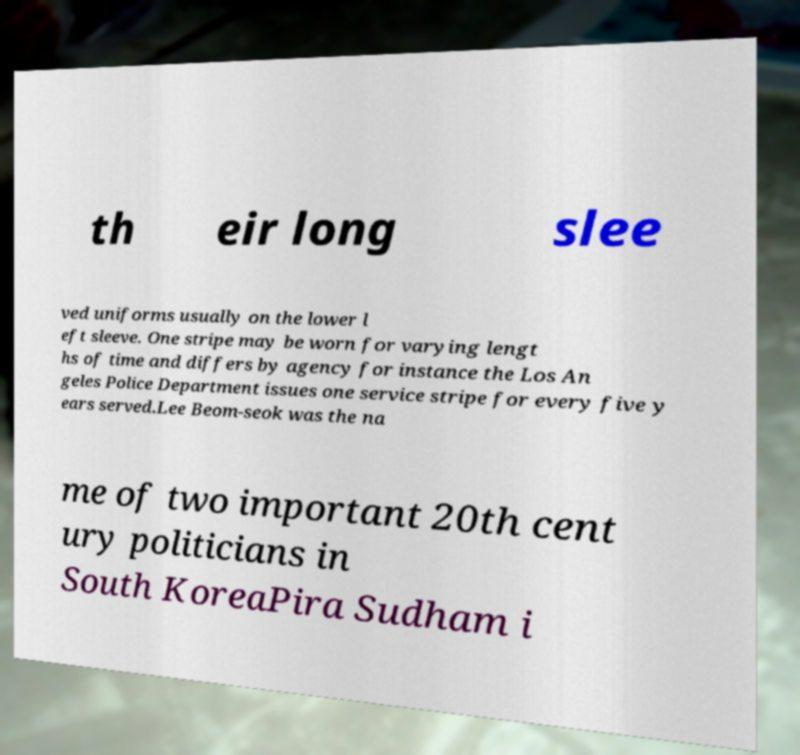Please read and relay the text visible in this image. What does it say? th eir long slee ved uniforms usually on the lower l eft sleeve. One stripe may be worn for varying lengt hs of time and differs by agency for instance the Los An geles Police Department issues one service stripe for every five y ears served.Lee Beom-seok was the na me of two important 20th cent ury politicians in South KoreaPira Sudham i 